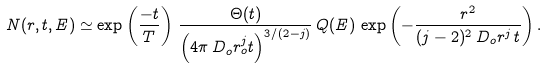<formula> <loc_0><loc_0><loc_500><loc_500>N ( r , t , E ) \simeq \exp \left ( \frac { - t } { T } \right ) \, \frac { \Theta ( t ) } { \left ( 4 \pi \, D _ { o } r _ { o } ^ { j } t \right ) ^ { 3 / ( 2 - j ) } } \, Q ( E ) \, \exp \left ( - \frac { r ^ { 2 } } { ( j - 2 ) ^ { 2 } \, D _ { o } r ^ { j } \, t } \right ) .</formula> 